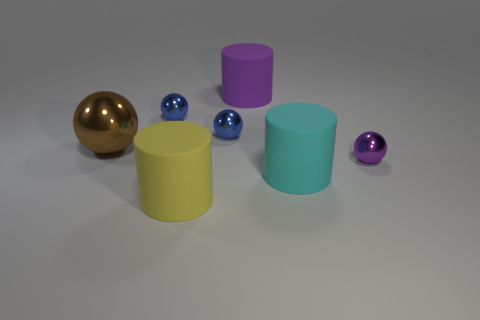Compare the sizes of the objects in the picture. The gold sphere is the largest object in the image. The cyan and yellow cylinders are medium-sized and of similar dimensions, yet slightly different in height. The blue and purple spheres are the smallest objects, with the purple sphere being the tiniest in the scene. 